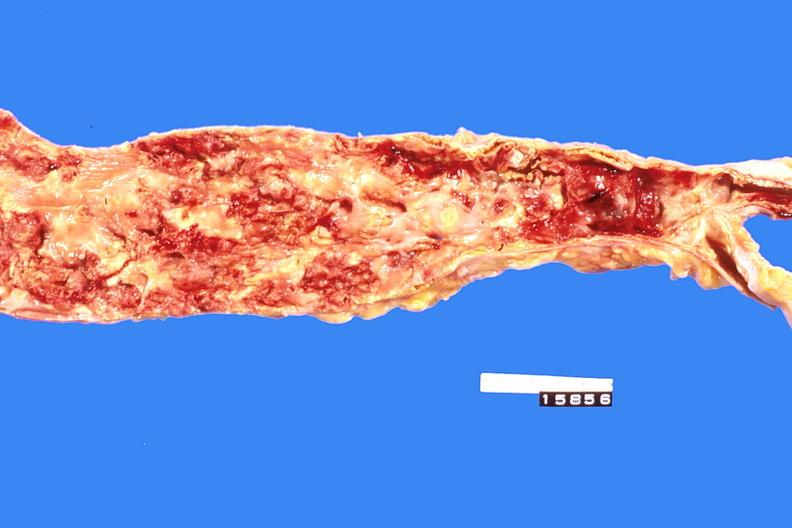s surface present?
Answer the question using a single word or phrase. No 